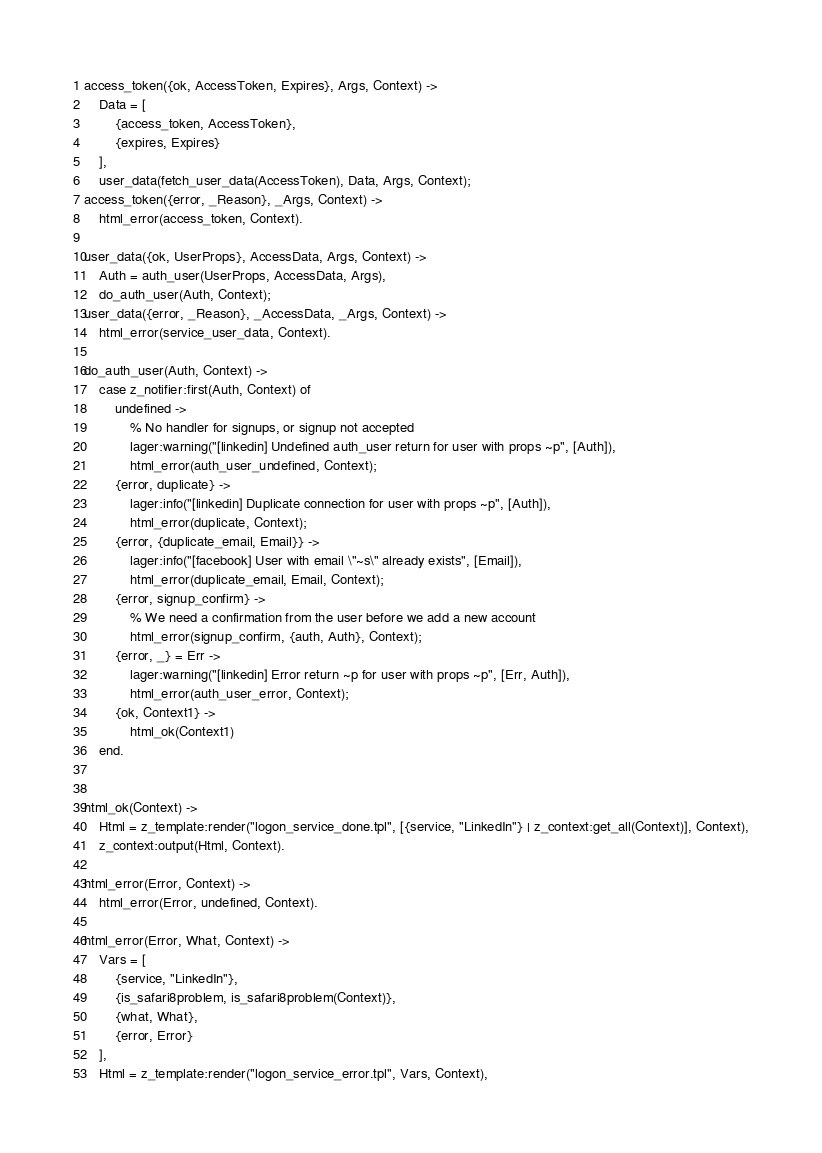<code> <loc_0><loc_0><loc_500><loc_500><_Erlang_>
access_token({ok, AccessToken, Expires}, Args, Context) ->
    Data = [
        {access_token, AccessToken},
        {expires, Expires}
    ],
    user_data(fetch_user_data(AccessToken), Data, Args, Context);
access_token({error, _Reason}, _Args, Context) ->
    html_error(access_token, Context).

user_data({ok, UserProps}, AccessData, Args, Context) ->
    Auth = auth_user(UserProps, AccessData, Args),
    do_auth_user(Auth, Context);
user_data({error, _Reason}, _AccessData, _Args, Context) ->
    html_error(service_user_data, Context).

do_auth_user(Auth, Context) ->
    case z_notifier:first(Auth, Context) of
        undefined ->
            % No handler for signups, or signup not accepted
            lager:warning("[linkedin] Undefined auth_user return for user with props ~p", [Auth]),
            html_error(auth_user_undefined, Context);
        {error, duplicate} ->
            lager:info("[linkedin] Duplicate connection for user with props ~p", [Auth]),
            html_error(duplicate, Context);
        {error, {duplicate_email, Email}} ->
            lager:info("[facebook] User with email \"~s\" already exists", [Email]),
            html_error(duplicate_email, Email, Context);
        {error, signup_confirm} ->
            % We need a confirmation from the user before we add a new account
            html_error(signup_confirm, {auth, Auth}, Context);
        {error, _} = Err ->
            lager:warning("[linkedin] Error return ~p for user with props ~p", [Err, Auth]),
            html_error(auth_user_error, Context);
        {ok, Context1} ->
            html_ok(Context1)
    end.


html_ok(Context) ->
    Html = z_template:render("logon_service_done.tpl", [{service, "LinkedIn"} | z_context:get_all(Context)], Context),
    z_context:output(Html, Context).

html_error(Error, Context) ->
    html_error(Error, undefined, Context).

html_error(Error, What, Context) ->
    Vars = [
        {service, "LinkedIn"},
        {is_safari8problem, is_safari8problem(Context)},
        {what, What},
        {error, Error}
    ],
    Html = z_template:render("logon_service_error.tpl", Vars, Context),</code> 